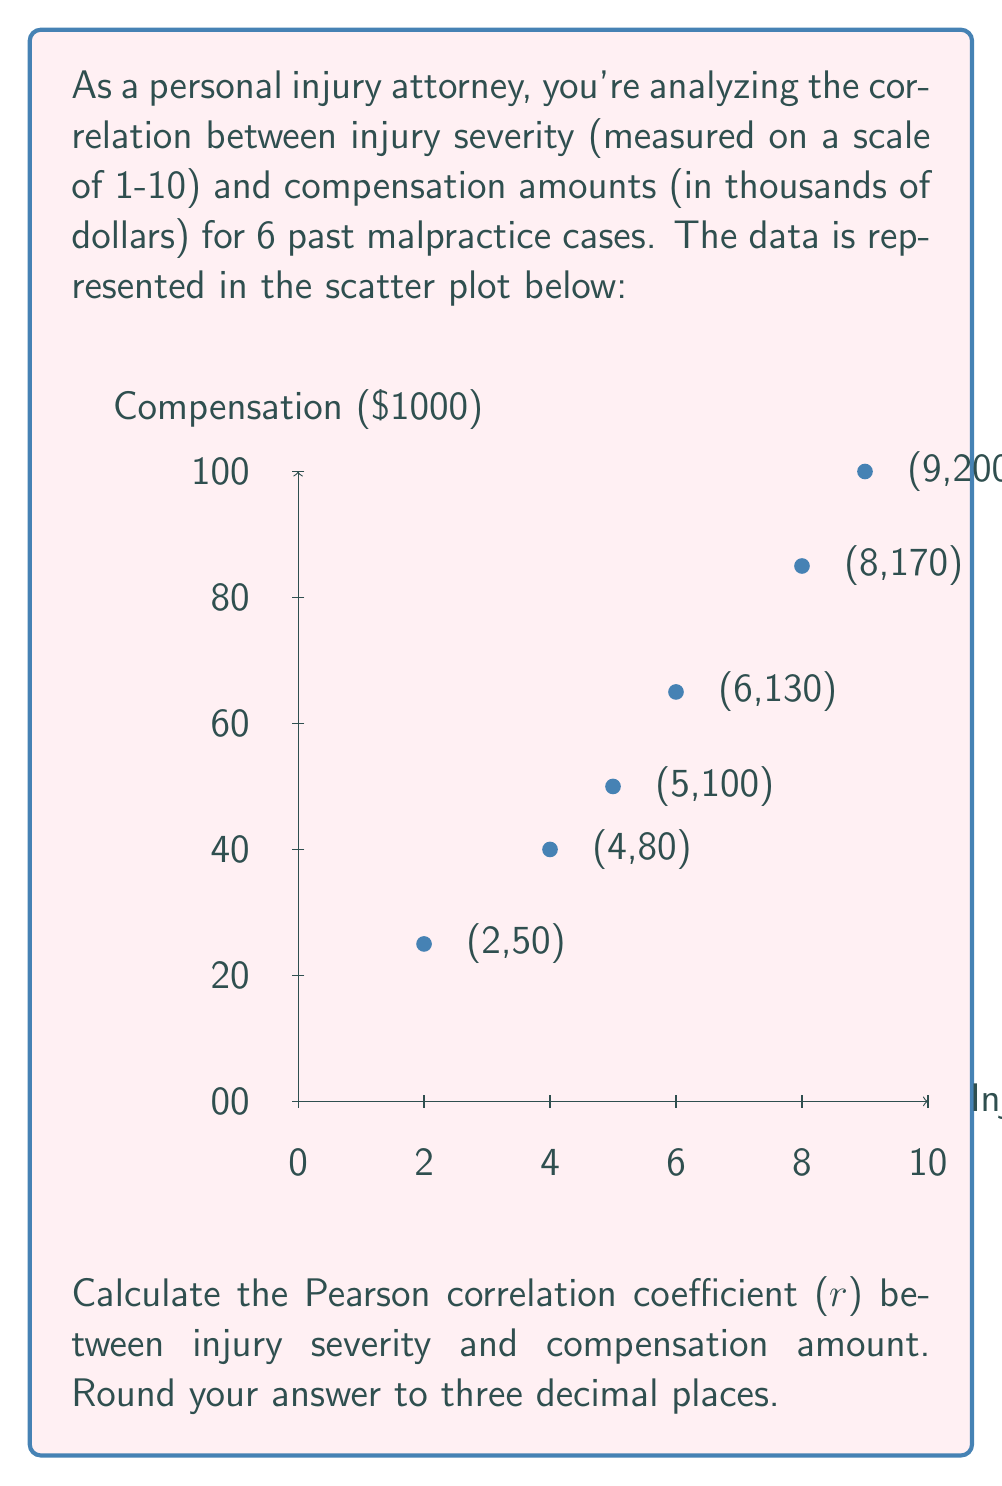Give your solution to this math problem. To calculate the Pearson correlation coefficient (r), we'll use the formula:

$$ r = \frac{\sum_{i=1}^{n} (x_i - \bar{x})(y_i - \bar{y})}{\sqrt{\sum_{i=1}^{n} (x_i - \bar{x})^2 \sum_{i=1}^{n} (y_i - \bar{y})^2}} $$

Where:
$x_i$ = injury severity scores
$y_i$ = compensation amounts
$\bar{x}$ = mean of injury severity scores
$\bar{y}$ = mean of compensation amounts
$n$ = number of cases (6)

Step 1: Calculate means
$\bar{x} = \frac{2+4+5+6+8+9}{6} = 5.67$
$\bar{y} = \frac{50+80+100+130+170+200}{6} = 121.67$

Step 2: Calculate $(x_i - \bar{x})$ and $(y_i - \bar{y})$ for each case
Step 3: Calculate $(x_i - \bar{x})^2$, $(y_i - \bar{y})^2$, and $(x_i - \bar{x})(y_i - \bar{y})$

| $x_i$ | $y_i$ | $(x_i - \bar{x})$ | $(y_i - \bar{y})$ | $(x_i - \bar{x})^2$ | $(y_i - \bar{y})^2$ | $(x_i - \bar{x})(y_i - \bar{y})$ |
|-------|-------|-------------------|-------------------|---------------------|---------------------|-----------------------------------|
| 2     | 50    | -3.67             | -71.67            | 13.47               | 5136.59             | 263.13                            |
| 4     | 80    | -1.67             | -41.67            | 2.79                | 1736.39             | 69.59                             |
| 5     | 100   | -0.67             | -21.67            | 0.45                | 469.59              | 14.52                             |
| 6     | 130   | 0.33              | 8.33              | 0.11                | 69.39               | 2.75                              |
| 8     | 170   | 2.33              | 48.33             | 5.43                | 2335.79             | 112.61                            |
| 9     | 200   | 3.33              | 78.33             | 11.09               | 6135.59             | 260.84                            |

Step 4: Sum the last three columns
$\sum (x_i - \bar{x})^2 = 33.34$
$\sum (y_i - \bar{y})^2 = 15883.34$
$\sum (x_i - \bar{x})(y_i - \bar{y}) = 723.44$

Step 5: Apply the formula
$$ r = \frac{723.44}{\sqrt{33.34 \times 15883.34}} = \frac{723.44}{728.01} = 0.9937 $$

Rounded to three decimal places: 0.994
Answer: 0.994 